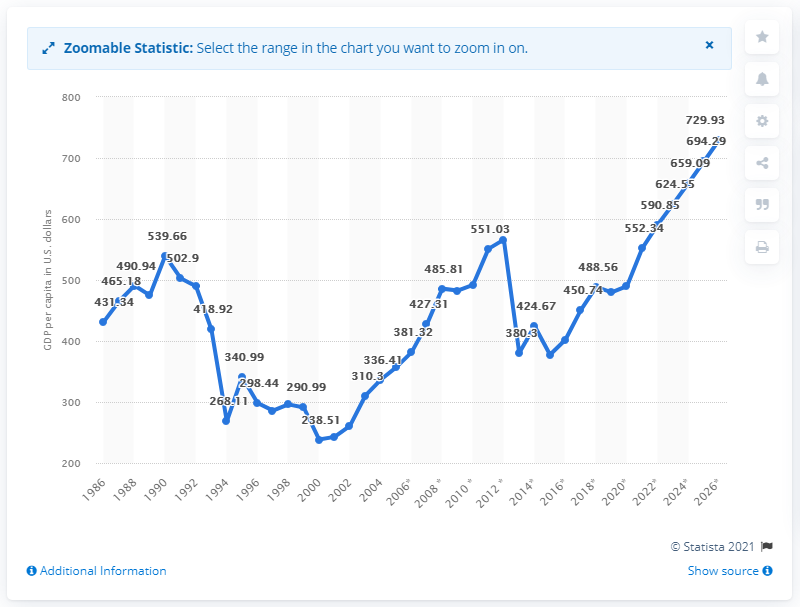Specify some key components in this picture. In 2020, the GDP per capita in the Central African Republic was 489.87. 